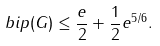Convert formula to latex. <formula><loc_0><loc_0><loc_500><loc_500>b i p ( G ) \leq \frac { e } { 2 } + \frac { 1 } { 2 } e ^ { 5 / 6 } .</formula> 